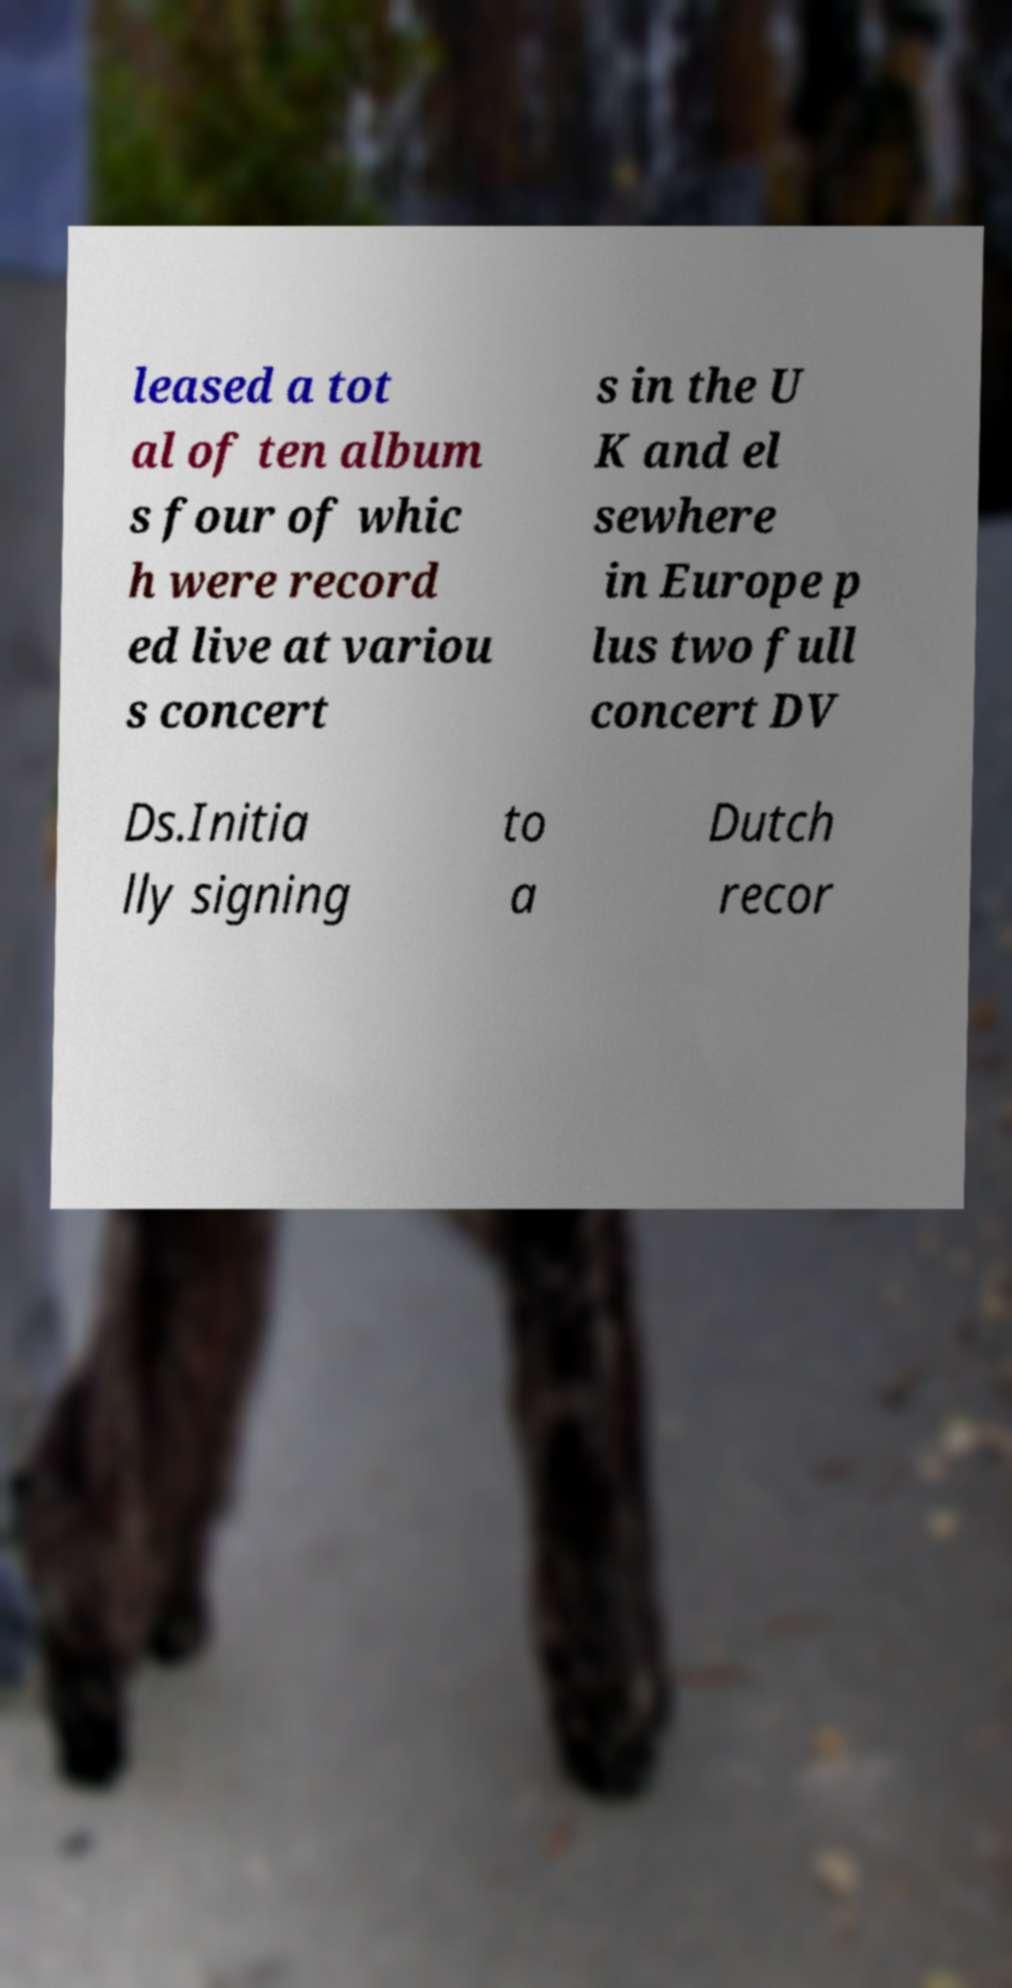Could you assist in decoding the text presented in this image and type it out clearly? leased a tot al of ten album s four of whic h were record ed live at variou s concert s in the U K and el sewhere in Europe p lus two full concert DV Ds.Initia lly signing to a Dutch recor 